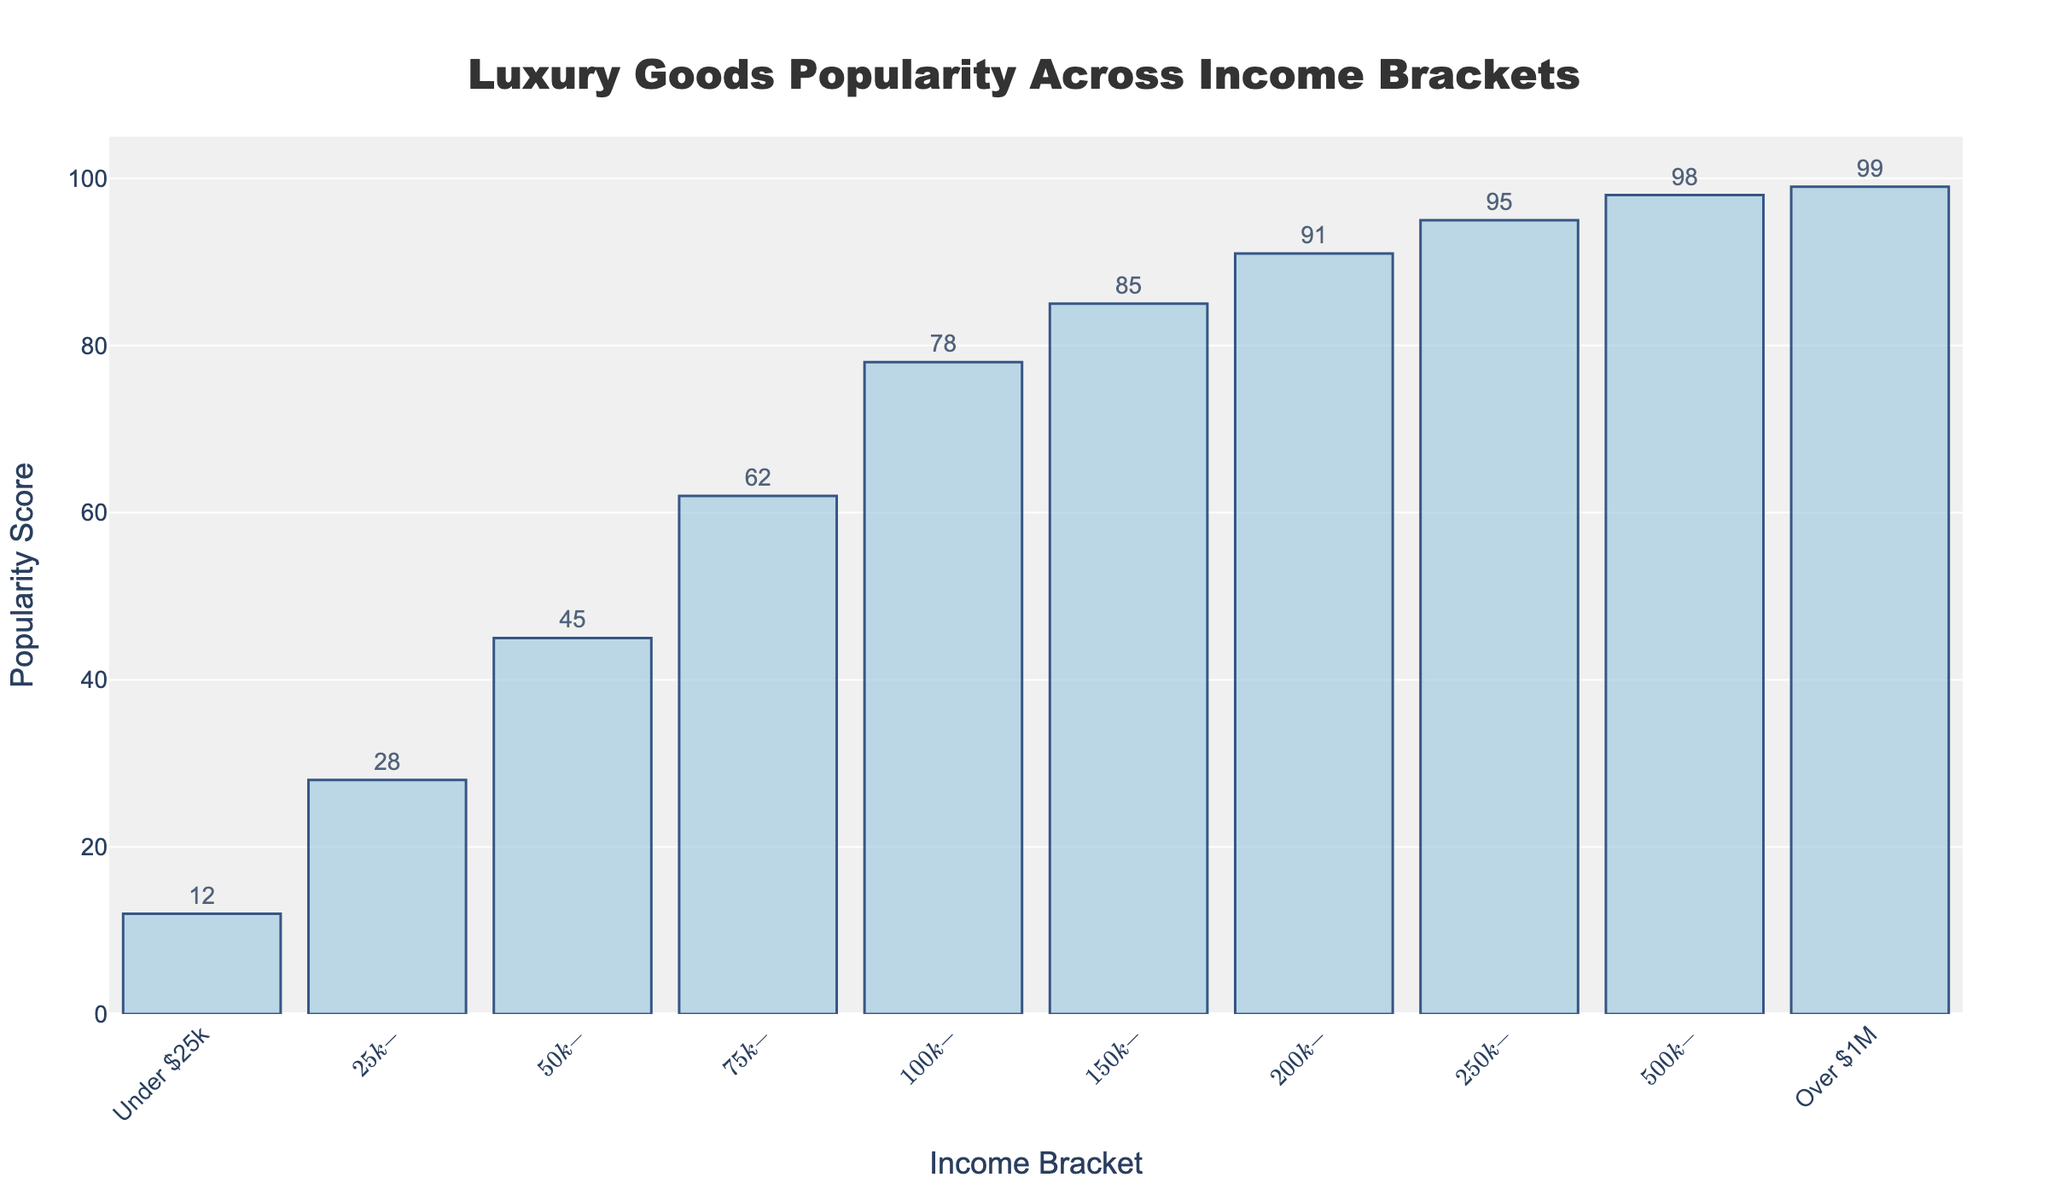What is the popularity score of luxury goods for the $50k-$75k income bracket? Refer to the bar labeled "$50k-$75k". The height of the bar corresponding to this income bracket gives the popularity score.
Answer: 45 Which income bracket has the highest popularity score for luxury goods? Look for the tallest bar among all income brackets. The bar labeled "Over $1M" is the tallest, indicating the highest popularity score.
Answer: Over $1M What is the difference in popularity scores between the $100k-$150k bracket and the $200k-$250k bracket? Identify the heights of the bars for the income brackets "$100k-$150k" and "$200k-$250k" which are 78 and 91 respectively. Subtract the smaller value from the larger one: 91 - 78.
Answer: 13 What is the average popularity score for income brackets under $75k? Sum the popularity scores for "Under $25k", "$25k-$50k", and "$50k-$75k". Then divide by the number of brackets: (12 + 28 + 45) / 3.
Answer: 28.33 Which two consecutive income brackets show the highest increase in popularity score? Compare the differences in popularity scores between consecutive income brackets. The largest increase is between "$50k-$75k" and "$75k-$100k", with the difference being 62 - 45.
Answer: $50k-$75k and $75k-$100k Is the popularity score for the $500k-$1M income bracket closer to the $250k-$500k income bracket or the over $1M income bracket? Compare the absolute differences between the popularity score of "$500k-$1M" (98) and "$250k-$500k" (95) and "Over $1M" (99):
Answer: $250k-$500k What is the range of popularity scores across all income brackets? The range is the difference between the highest and lowest popularity scores. Identify the highest (Over $1M: 99) and lowest (Under $25k: 12) values and subtract: 99 - 12.
Answer: 87 How many income brackets have a popularity score above 50? Count the bars with heights greater than 50. The income brackets "$75k-$100k", "$100k-$150k", "$150k-$200k", "$200k-$250k", "$250k-$500k", "$500k-$1M", and "Over $1M" meet this criterion.
Answer: 7 What percentage of the total does the popularity score of the $150k-$200k income bracket represent? Sum all popularity scores: 12 + 28 + 45 + 62 + 78 + 85 + 91 + 95 + 98 + 99 = 693. Then, calculate the percentage that the score of $150k-$200k (85) represents: (85 / 693) * 100.
Answer: 12.26 Which income bracket has a popularity score that is exactly 50 units higher than the lowest score? The lowest score is 12 (Under $25k). Adding 50 to 12 gives 62, and the bar with this popularity score corresponds to $75k-$100k.
Answer: $75k-$100k 